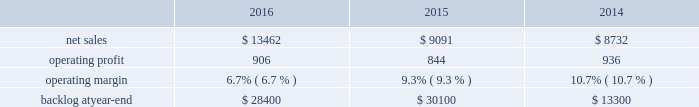2015 compared to 2014 mfc 2019s net sales in 2015 decreased $ 322 million , or 5% ( 5 % ) , compared to the same period in 2014 .
The decrease was attributable to lower net sales of approximately $ 345 million for air and missile defense programs due to fewer deliveries ( primarily pac-3 ) and lower volume ( primarily thaad ) ; and approximately $ 85 million for tactical missile programs due to fewer deliveries ( primarily guided multiple launch rocket system ( gmlrs ) ) and joint air-to-surface standoff missile , partially offset by increased deliveries for hellfire .
These decreases were partially offset by higher net sales of approximately $ 55 million for energy solutions programs due to increased volume .
Mfc 2019s operating profit in 2015 decreased $ 62 million , or 5% ( 5 % ) , compared to 2014 .
The decrease was attributable to lower operating profit of approximately $ 100 million for fire control programs due primarily to lower risk retirements ( primarily lantirn and sniper ) ; and approximately $ 65 million for tactical missile programs due to lower risk retirements ( primarily hellfire and gmlrs ) and fewer deliveries .
These decreases were partially offset by higher operating profit of approximately $ 75 million for air and missile defense programs due to increased risk retirements ( primarily thaad ) .
Adjustments not related to volume , including net profit booking rate adjustments and other matters , were approximately $ 60 million lower in 2015 compared to 2014 .
Backlog backlog decreased in 2016 compared to 2015 primarily due to lower orders on pac-3 , hellfire , and jassm .
Backlog increased in 2015 compared to 2014 primarily due to higher orders on pac-3 , lantirn/sniper and certain tactical missile programs , partially offset by lower orders on thaad .
Trends we expect mfc 2019s net sales to increase in the mid-single digit percentage range in 2017 as compared to 2016 driven primarily by our air and missile defense programs .
Operating profit is expected to be flat or increase slightly .
Accordingly , operating profit margin is expected to decline from 2016 levels as a result of contract mix and fewer risk retirements in 2017 compared to 2016 .
Rotary and mission systems as previously described , on november 6 , 2015 , we acquired sikorsky and aligned the sikorsky business under our rms business segment .
The 2015 results of the acquired sikorsky business have been included in our financial results from the november 6 , 2015 acquisition date through december 31 , 2015 .
As a result , our consolidated operating results and rms business segment operating results for the year ended december 31 , 2015 do not reflect a full year of sikorsky operations .
Our rms business segment provides design , manufacture , service and support for a variety of military and civil helicopters , ship and submarine mission and combat systems ; mission systems and sensors for rotary and fixed-wing aircraft ; sea and land-based missile defense systems ; radar systems ; the littoral combat ship ( lcs ) ; simulation and training services ; and unmanned systems and technologies .
In addition , rms supports the needs of government customers in cybersecurity and delivers communication and command and control capabilities through complex mission solutions for defense applications .
Rms 2019 major programs include black hawk and seahawk helicopters , aegis combat system ( aegis ) , lcs , space fence , advanced hawkeye radar system , tpq-53 radar system , ch-53k development helicopter , and vh-92a helicopter program .
Rms 2019 operating results included the following ( in millions ) : .
2016 compared to 2015 rms 2019 net sales in 2016 increased $ 4.4 billion , or 48% ( 48 % ) , compared to 2015 .
The increase was primarily attributable to higher net sales of approximately $ 4.6 billion from sikorsky , which was acquired on november 6 , 2015 .
Net sales for 2015 include sikorsky 2019s results subsequent to the acquisition date , net of certain revenue adjustments required to account for the acquisition of this business .
This increase was partially offset by lower net sales of approximately $ 70 million for training .
What were average operating profit for rms in millions between 2014 and 2016? 
Computations: table_average(operating profit, none)
Answer: 895.33333. 